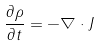Convert formula to latex. <formula><loc_0><loc_0><loc_500><loc_500>\frac { \partial \rho } { \partial t } = - \nabla \cdot J</formula> 